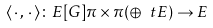<formula> <loc_0><loc_0><loc_500><loc_500>\langle \, \cdot \, , \, \cdot \, \rangle \colon E [ G ] \pi \times \pi ( \oplus _ { \ } t E ) \to E</formula> 